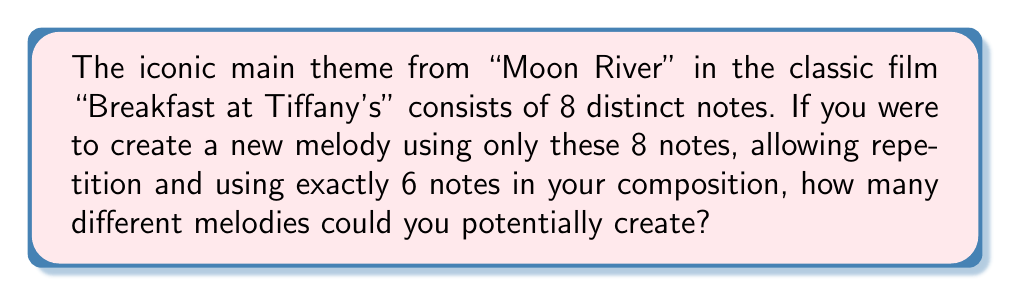Can you answer this question? Let's approach this step-by-step:

1) We have 8 distinct notes to choose from for each position in our 6-note melody.

2) For each position, we can use any of the 8 notes, and we can repeat notes.

3) This scenario is a perfect example of the multiplication principle in combinatorics.

4) For each of the 6 positions in our melody, we have 8 choices.

5) Therefore, the total number of possible melodies is:

   $$ 8 \times 8 \times 8 \times 8 \times 8 \times 8 $$

6) This can be written more concisely as:

   $$ 8^6 $$

7) Calculating this:

   $$ 8^6 = 8 \times 8 \times 8 \times 8 \times 8 \times 8 = 262,144 $$

Thus, there are 262,144 possible distinct melodies that can be created under these conditions.
Answer: 262,144 